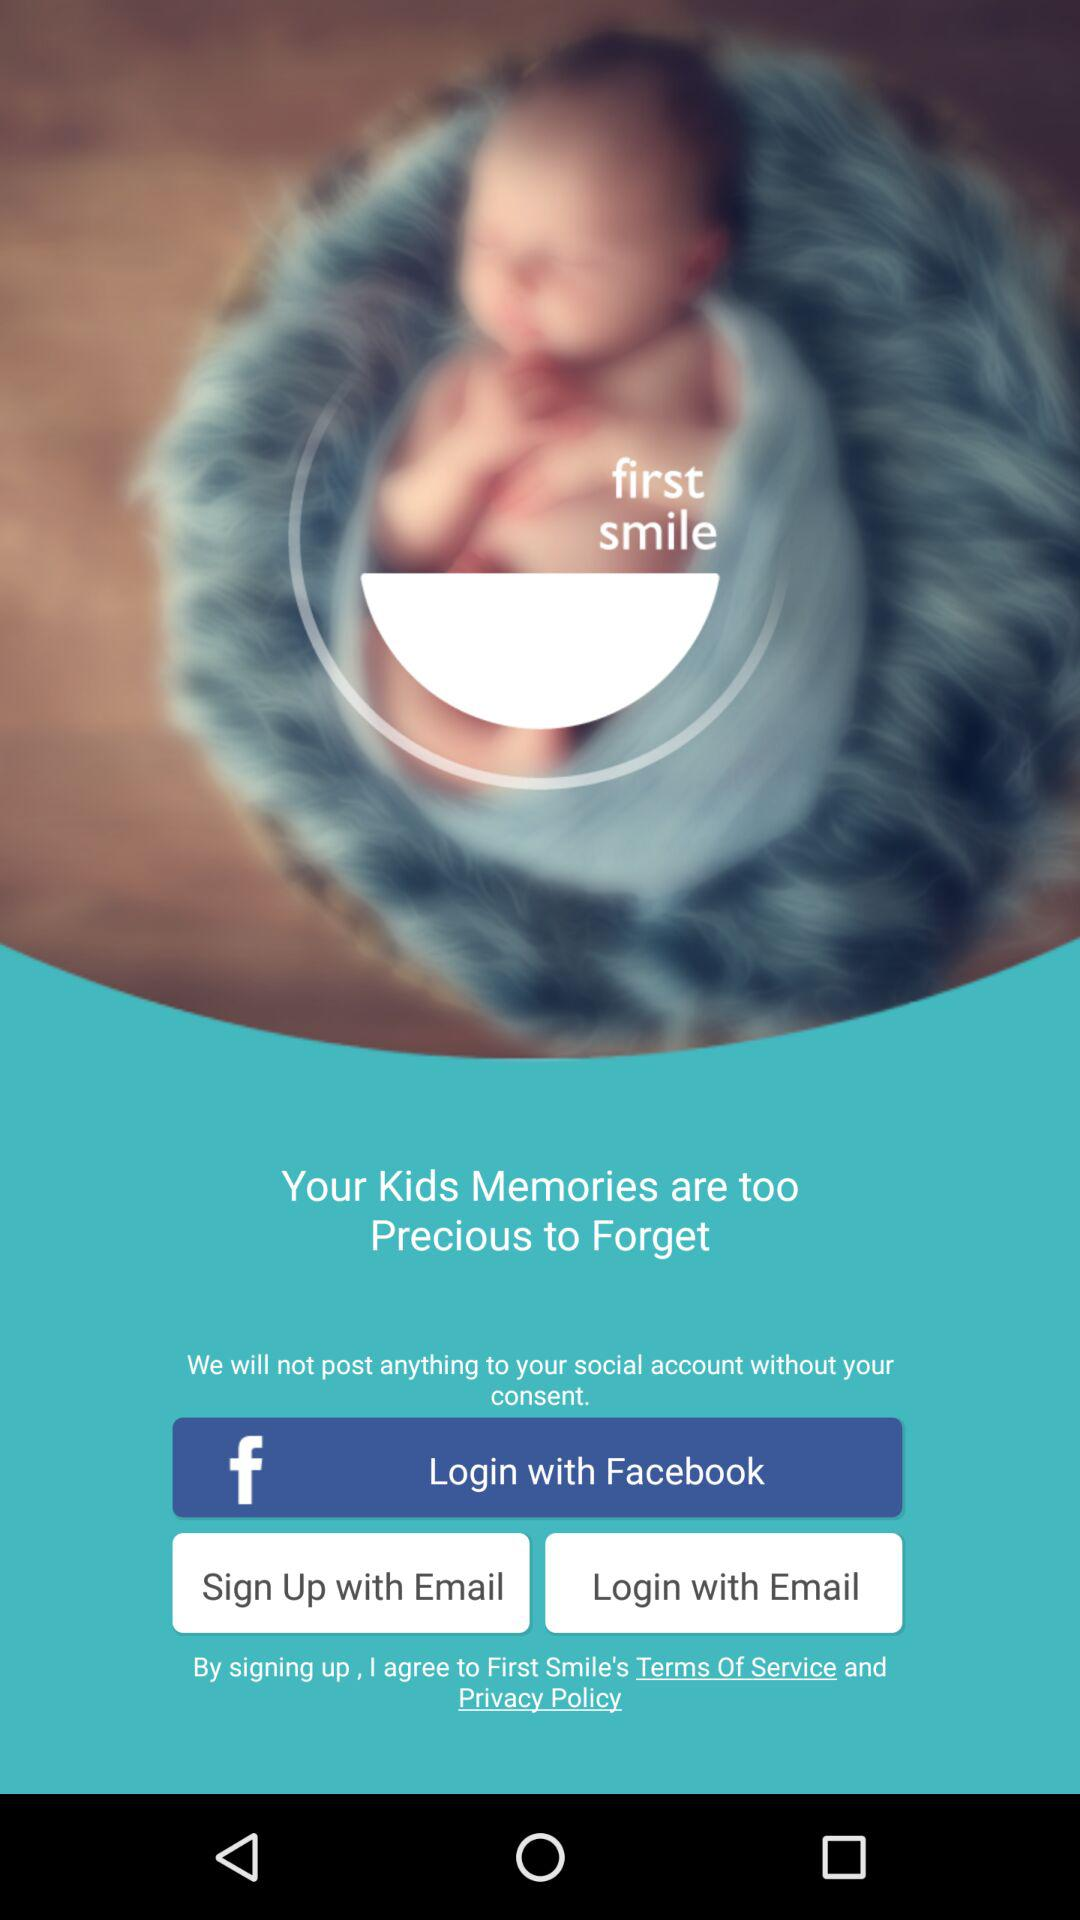What are the login options? The login options are "Facebook" and "Email". 